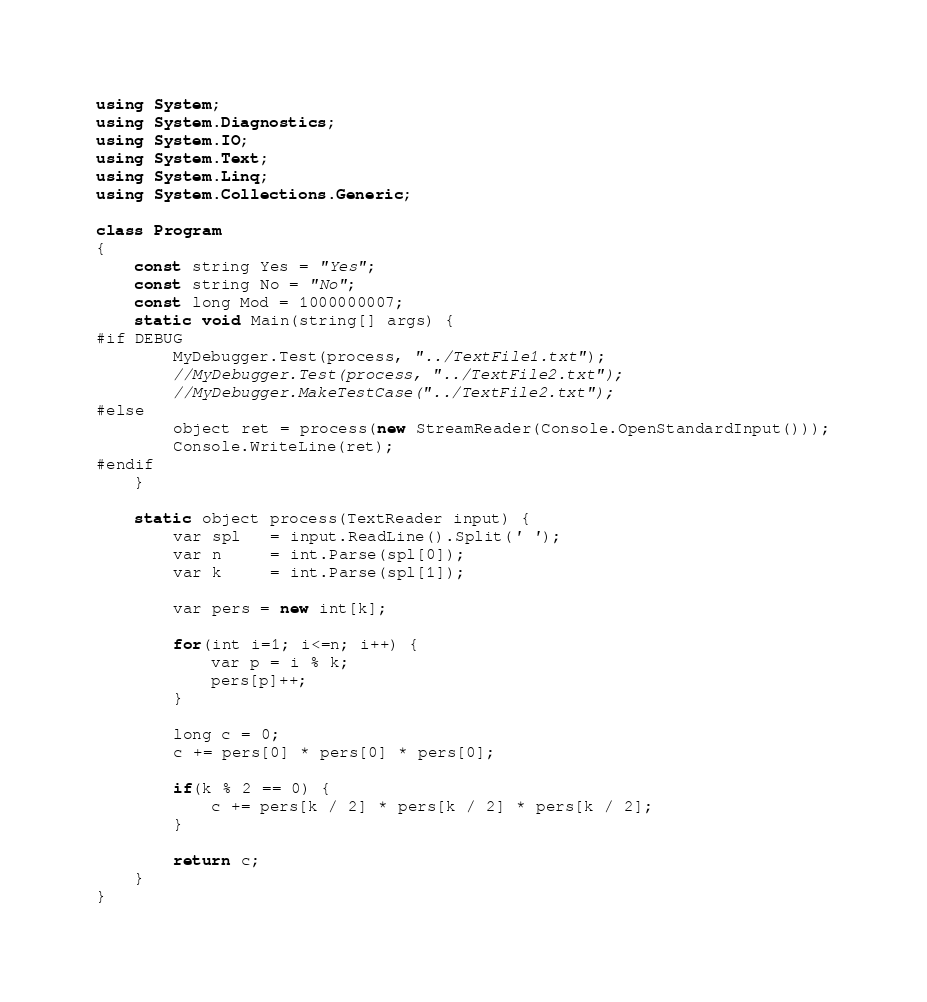Convert code to text. <code><loc_0><loc_0><loc_500><loc_500><_C#_>using System;
using System.Diagnostics;
using System.IO;
using System.Text;
using System.Linq;
using System.Collections.Generic;

class Program
{
    const string Yes = "Yes";
    const string No = "No";
    const long Mod = 1000000007;
    static void Main(string[] args) {
#if DEBUG
        MyDebugger.Test(process, "../TextFile1.txt");
        //MyDebugger.Test(process, "../TextFile2.txt");
        //MyDebugger.MakeTestCase("../TextFile2.txt");
#else
        object ret = process(new StreamReader(Console.OpenStandardInput()));
        Console.WriteLine(ret);
#endif
    }

    static object process(TextReader input) {
        var spl   = input.ReadLine().Split(' ');
        var n     = int.Parse(spl[0]);
        var k     = int.Parse(spl[1]);

        var pers = new int[k];

        for(int i=1; i<=n; i++) {
            var p = i % k;
            pers[p]++;
        }

        long c = 0;
        c += pers[0] * pers[0] * pers[0];

        if(k % 2 == 0) {
            c += pers[k / 2] * pers[k / 2] * pers[k / 2];
        }

        return c;
    }
}</code> 